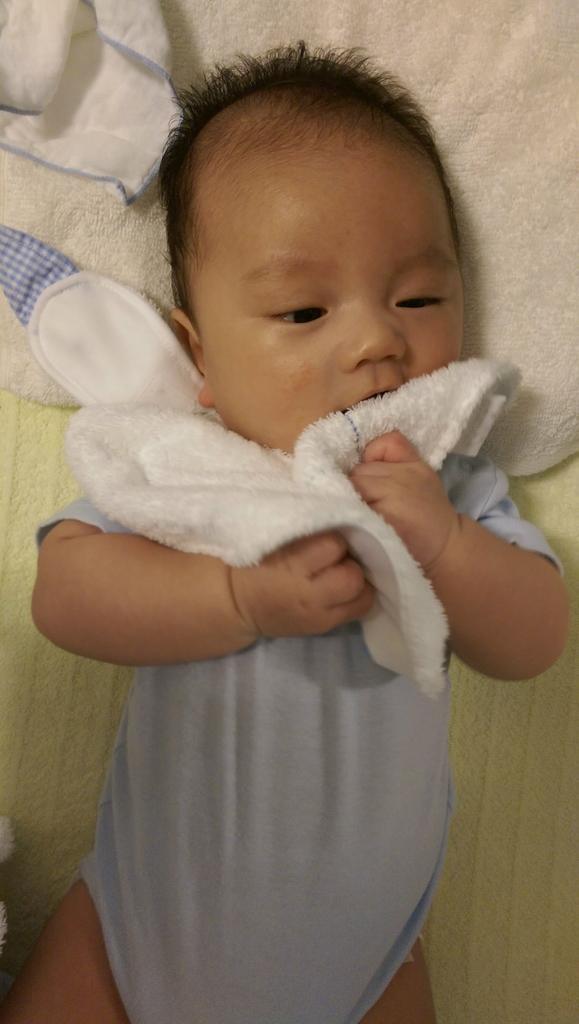Describe this image in one or two sentences. In this Image I can see a baby sleeping on the cream and white color cloth. Baby is wearing blue dress and holding white cloth. 